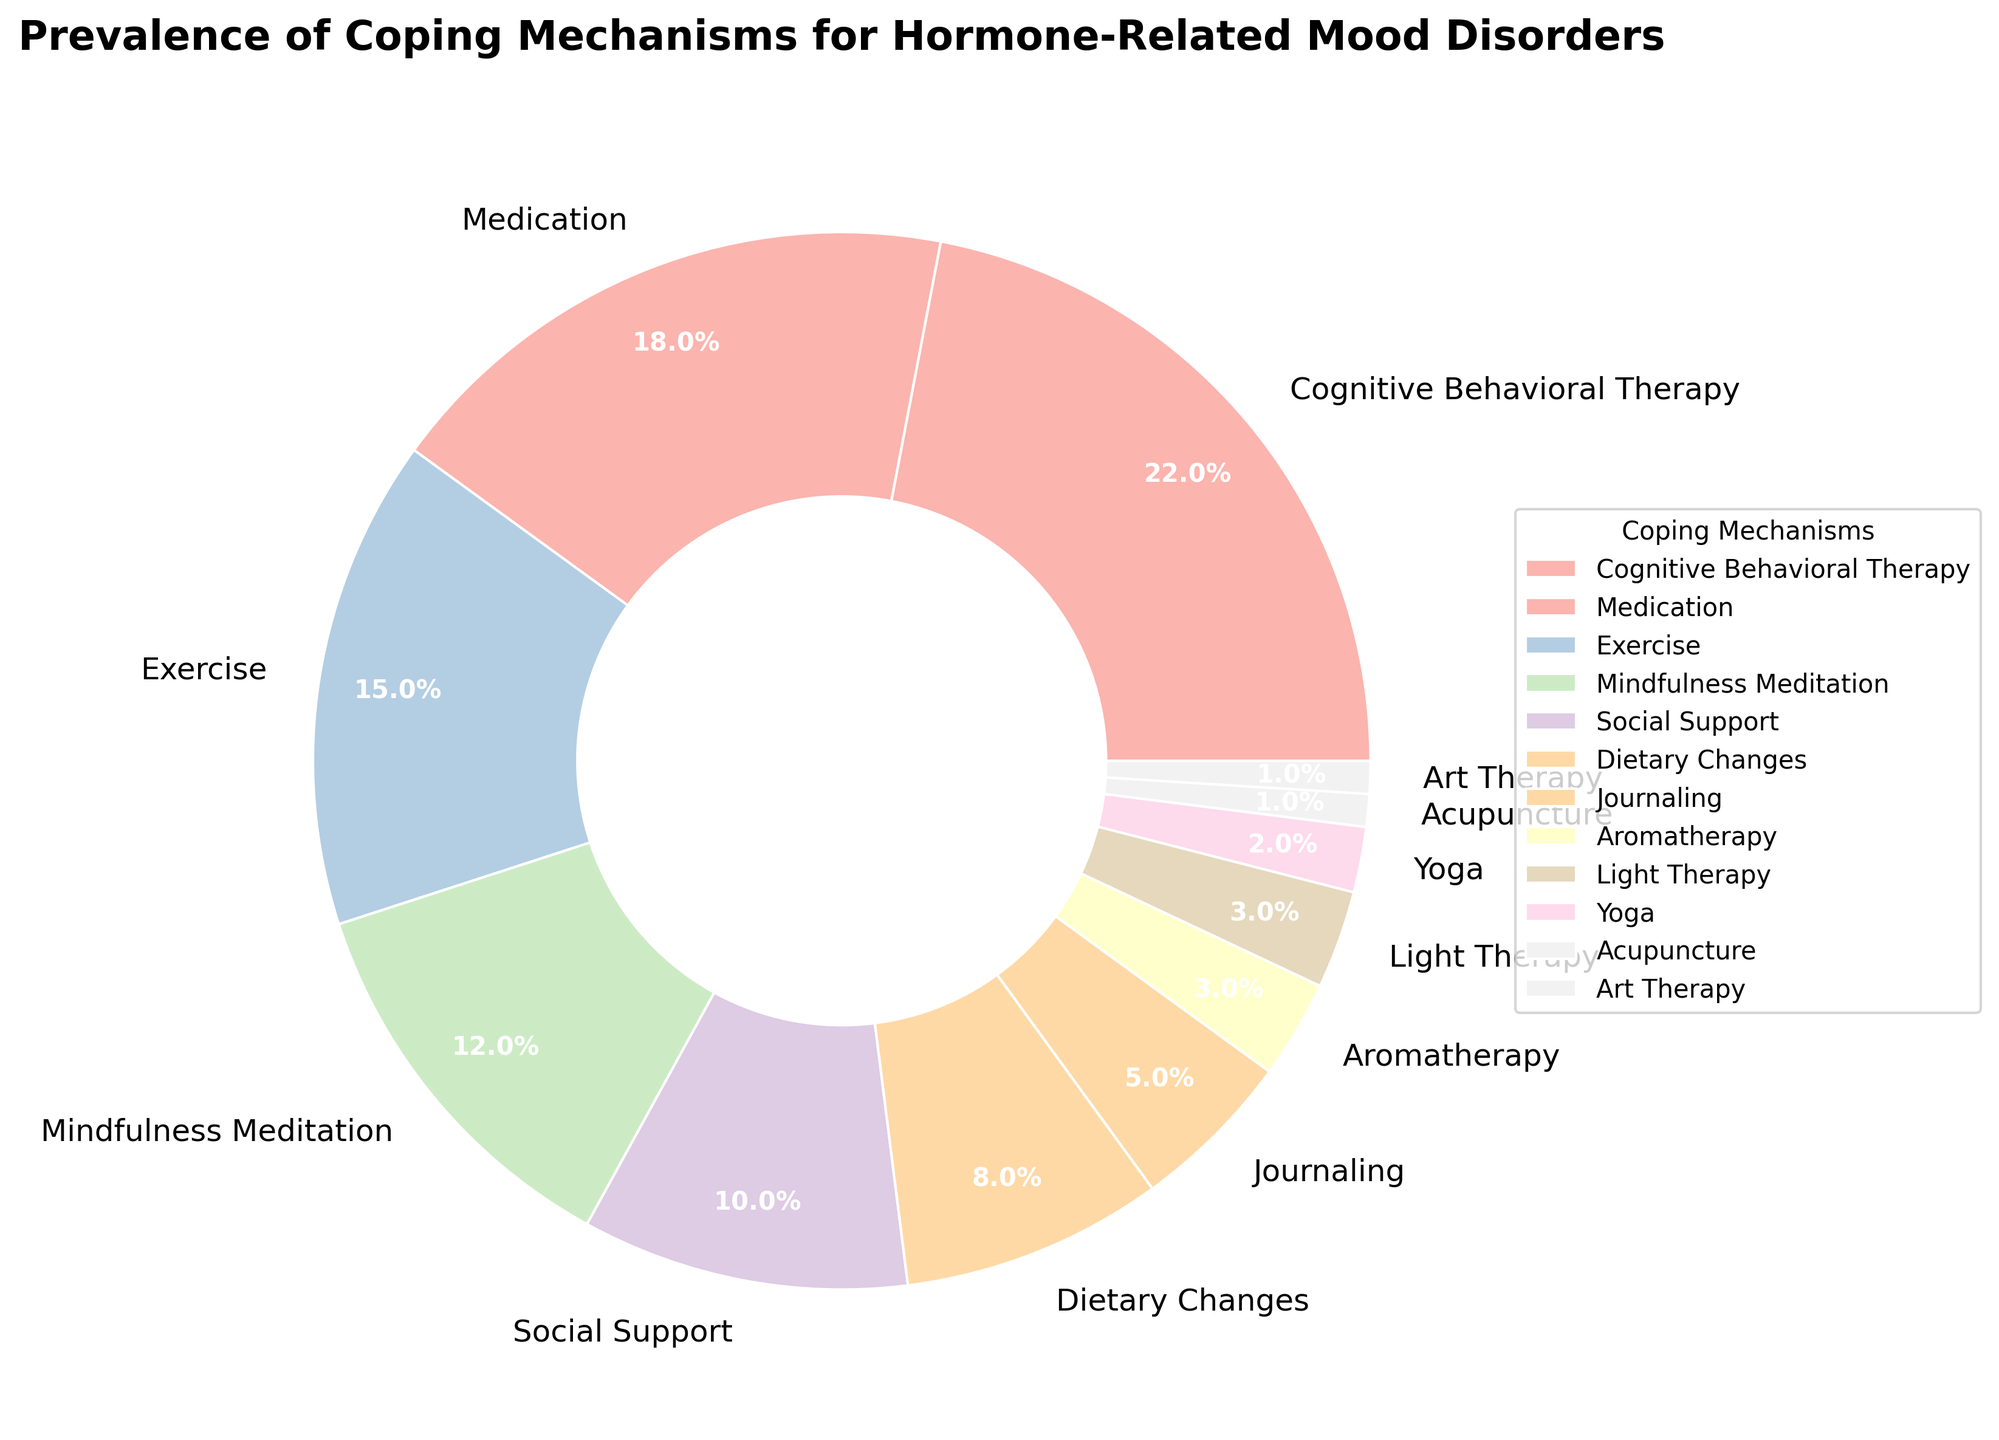What is the most prevalent coping mechanism for hormone-related mood disorders? The largest section of the pie chart represents Cognitive Behavioral Therapy with 22%. Therefore, Cognitive Behavioral Therapy is the most prevalent coping mechanism.
Answer: Cognitive Behavioral Therapy Which coping mechanism is used less frequently: Exercise or Mindfulness Meditation? Comparing the two sections of the pie chart, Exercise represents 15% while Mindfulness Meditation represents 12%. Therefore, Mindfulness Meditation is used less frequently than Exercise.
Answer: Mindfulness Meditation What is the combined percentage of individuals using Journaling and Aromatherapy? According to the pie chart, Journaling represents 5% and Aromatherapy represents 3%. Adding these percentages together: 5% + 3% = 8%.
Answer: 8% How many coping mechanisms have a prevalence of 10% or less? From the pie chart, the prevalence figures for Social Support, Dietary Changes, Journaling, Aromatherapy, Light Therapy, Yoga, Acupuncture, and Art Therapy are 10%, 8%, 5%, 3%, 3%, 2%, 1%, and 1% respectively. There are 8 coping mechanisms with a prevalence of 10% or less.
Answer: 8 Which has a higher prevalence: Social Support or Dietary Changes? The pie chart shows Social Support at 10% and Dietary Changes at 8%. Thus, Social Support has a higher prevalence than Dietary Changes.
Answer: Social Support What is the difference in percentage between the most and least prevalent coping mechanisms? The most prevalent coping mechanism is Cognitive Behavioral Therapy at 22%, and the least prevalent are Acupuncture and Art Therapy, each at 1%. The difference is 22% - 1% = 21%.
Answer: 21% If you combine the prevalence of Medication, Exercise, and Yoga, what is the total percentage? From the pie chart, the prevalence is 18% for Medication, 15% for Exercise, and 2% for Yoga. Summing these up: 18% + 15% + 2% = 35%.
Answer: 35% What is the average percentage of the top four coping mechanisms? The top four coping mechanisms by prevalence are Cognitive Behavioral Therapy (22%), Medication (18%), Exercise (15%), and Mindfulness Meditation (12%). The average is calculated by summing these percentages and dividing by four: (22% + 18% + 15% + 12%) / 4 = 67% / 4 = 16.75%.
Answer: 16.75% Compare the prevalence of Light Therapy and Yoga. Which is more frequently used? The pie chart indicates that Light Therapy has a prevalence of 3% and Yoga has a prevalence of 2%. Therefore, Light Therapy is more frequently used than Yoga.
Answer: Light Therapy 